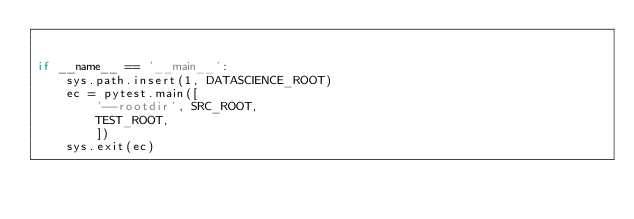<code> <loc_0><loc_0><loc_500><loc_500><_Python_>

if __name__ == '__main__':
    sys.path.insert(1, DATASCIENCE_ROOT)
    ec = pytest.main([
        '--rootdir', SRC_ROOT,
        TEST_ROOT,
        ])
    sys.exit(ec)
</code> 